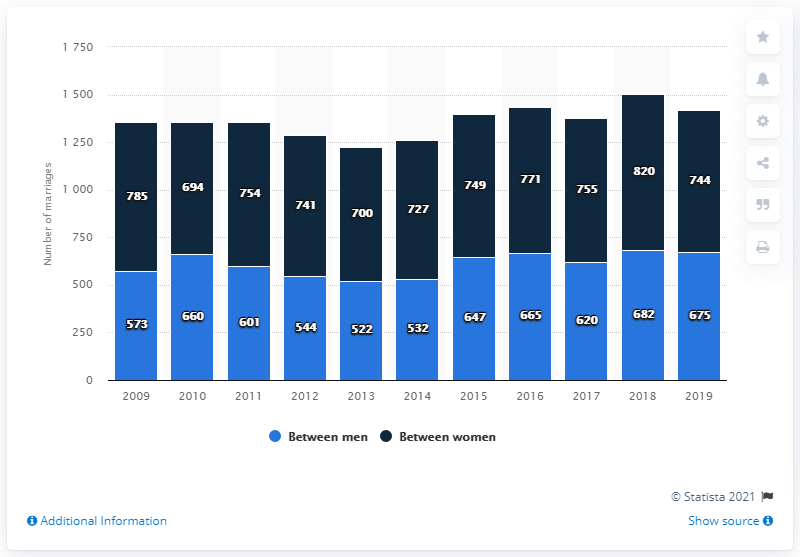Outline some significant characteristics in this image. The sum of 2018 and 2019 is 2921. In 2019, a total of 744 same-sex marriages between two women were recorded. In 2019, a total of 675 same-sex marriages between two men took place. In 2018, among women between the ages of 20 and 30, there were those who scored above 800 on the test. 